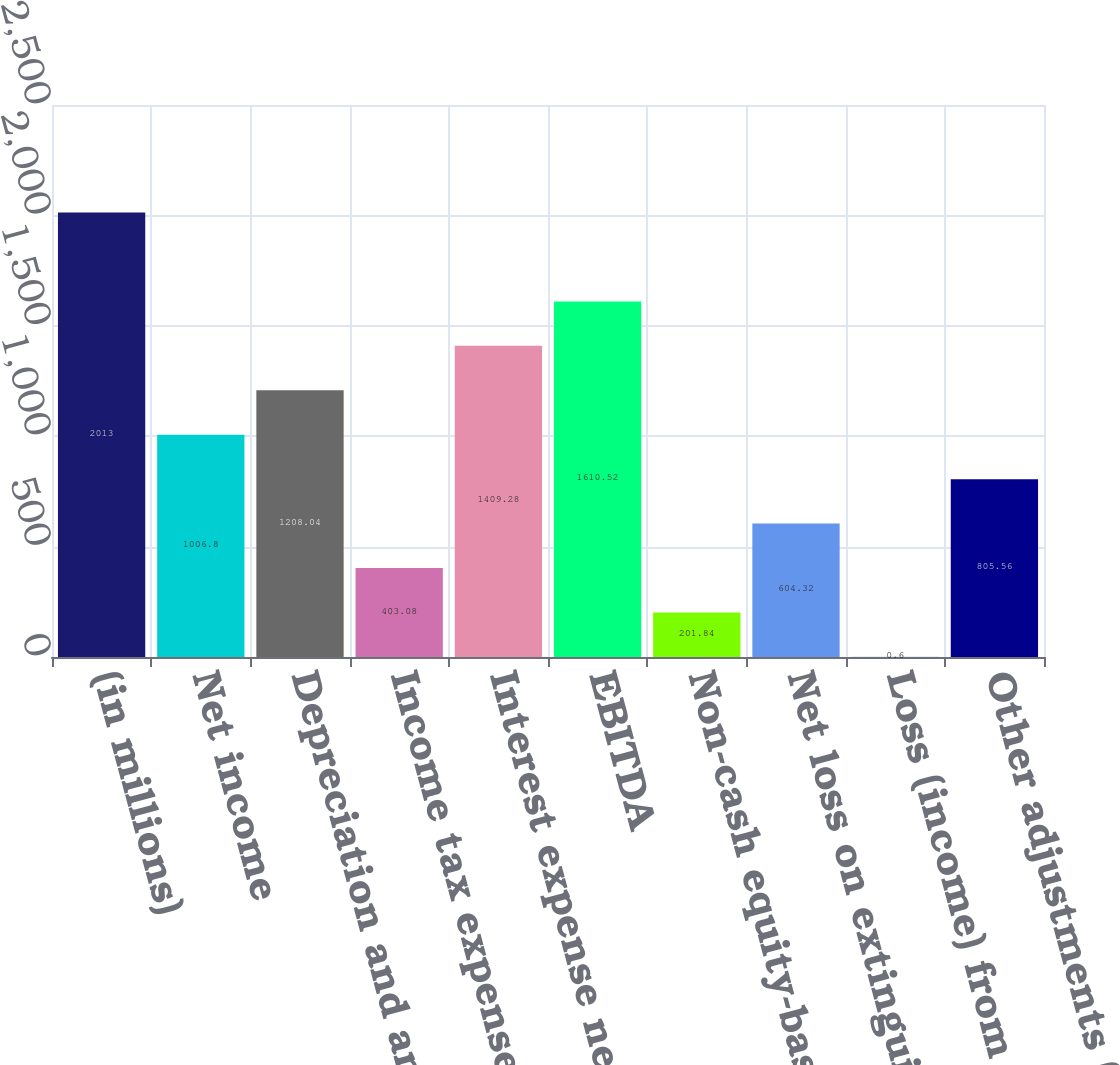Convert chart. <chart><loc_0><loc_0><loc_500><loc_500><bar_chart><fcel>(in millions)<fcel>Net income<fcel>Depreciation and amortization<fcel>Income tax expense<fcel>Interest expense net<fcel>EBITDA<fcel>Non-cash equity-based<fcel>Net loss on extinguishment of<fcel>Loss (income) from equity<fcel>Other adjustments (e)<nl><fcel>2013<fcel>1006.8<fcel>1208.04<fcel>403.08<fcel>1409.28<fcel>1610.52<fcel>201.84<fcel>604.32<fcel>0.6<fcel>805.56<nl></chart> 